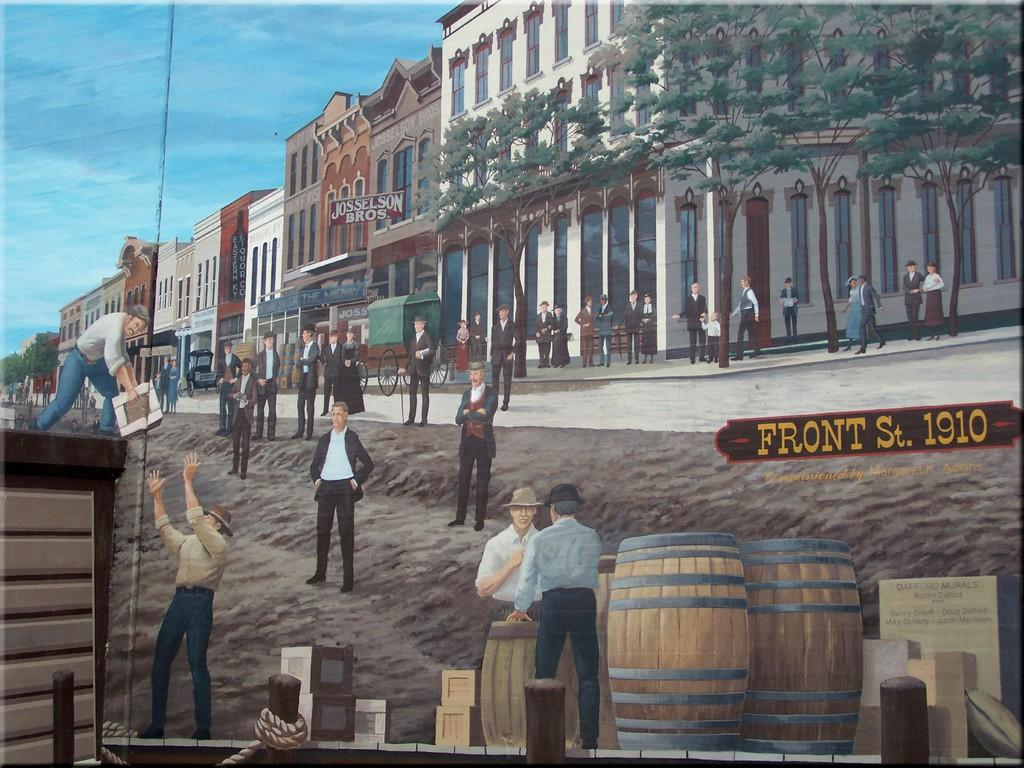<image>
Describe the image concisely. A painted image of Front Street life in 1910. 